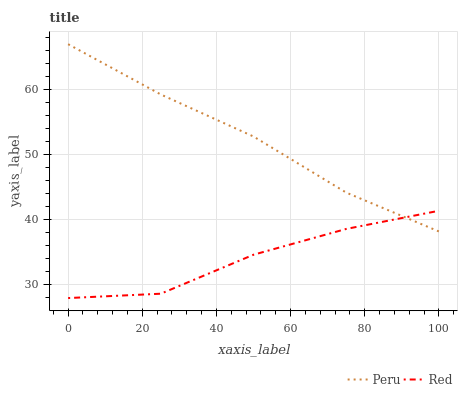Does Red have the minimum area under the curve?
Answer yes or no. Yes. Does Peru have the maximum area under the curve?
Answer yes or no. Yes. Does Peru have the minimum area under the curve?
Answer yes or no. No. Is Peru the smoothest?
Answer yes or no. Yes. Is Red the roughest?
Answer yes or no. Yes. Is Peru the roughest?
Answer yes or no. No. Does Peru have the lowest value?
Answer yes or no. No. Does Peru have the highest value?
Answer yes or no. Yes. 